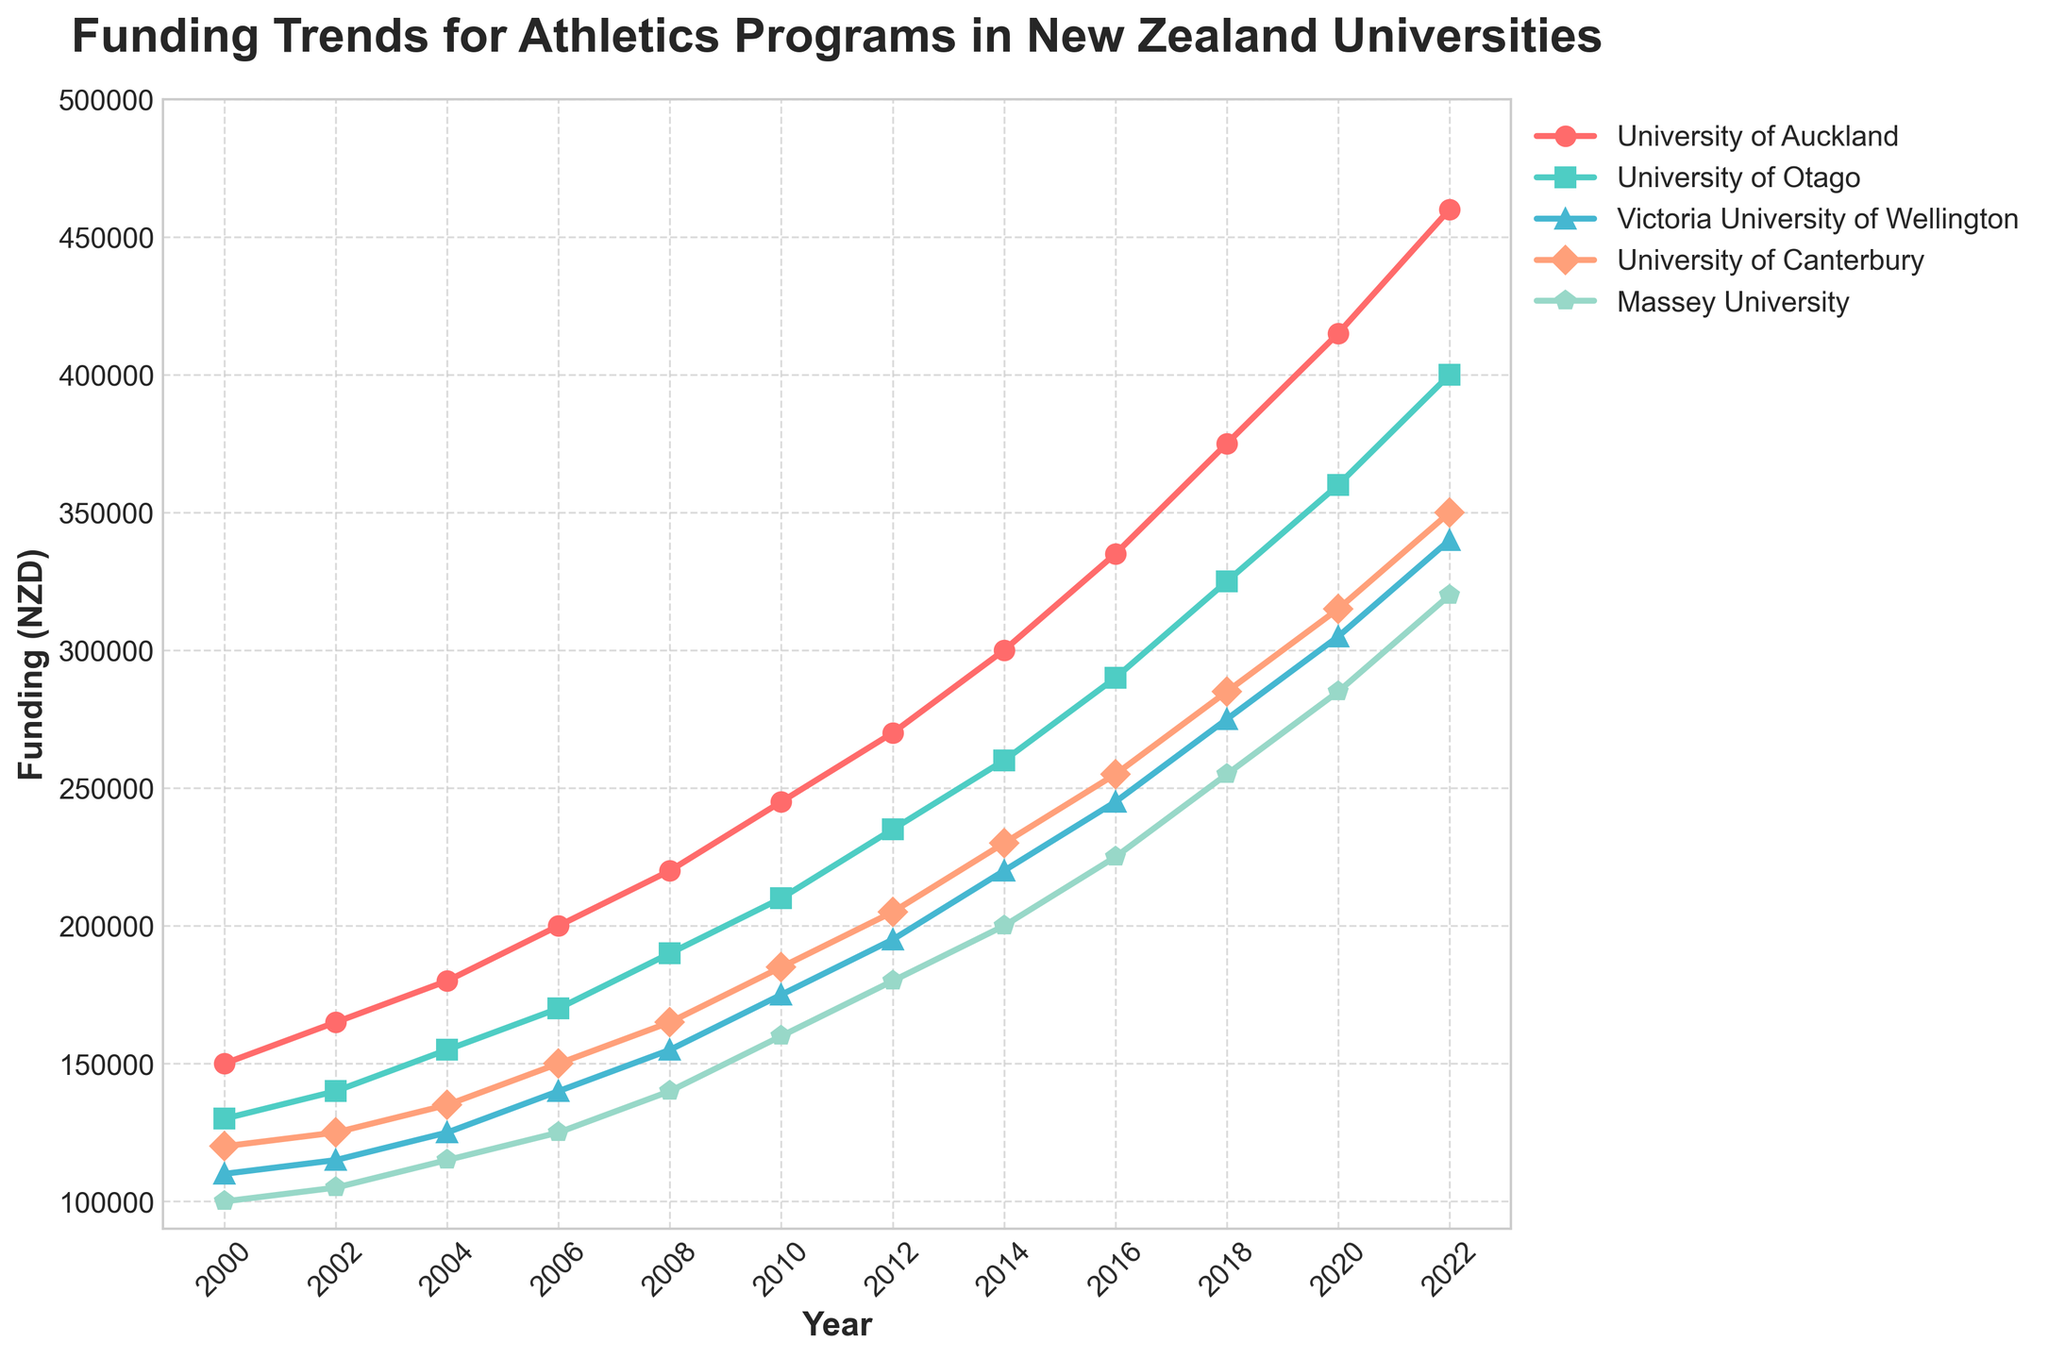What's the overall trend for funding in the University of Auckland from 2000 to 2022? The trend for the University of Auckland from 2000 to 2022 is increasing, starting at 150,000 NZD in 2000 and reaching 460,000 NZD in 2022. This indicates a continuous growth in funding over the years.
Answer: Increasing Which university had the highest funding in 2022? To determine the highest funding in 2022, analyze the values for each university in that year. The University of Auckland had the highest funding at 460,000 NZD.
Answer: University of Auckland How does the funding for the University of Otago in 2010 compare to its funding in 2020? The funding for the University of Otago in 2010 was 210,000 NZD and its funding in 2020 was 360,000 NZD. The funding increased by 150,000 NZD over this period.
Answer: Increased by 150,000 NZD Which university showed the least increase in funding from 2000 to 2022? To find the least increase, calculate the difference for each university from 2000 to 2022: 
- University of Auckland: 460,000 - 150,000 = 310,000
- University of Otago: 400,000 - 130,000 = 270,000
- Victoria University of Wellington: 340,000 - 110,000 = 230,000
- University of Canterbury: 350,000 - 120,000 = 230,000
- Massey University: 320,000 - 100,000 = 220,000
Massey University had the least increase of 220,000 NZD.
Answer: Massey University In which year did Massey University’s funding reach 200,000 NZD? Look for the first year where Massey University's funding is at least 200,000 NZD. This occurred in 2014, when the funding was 200,000 NZD.
Answer: 2014 What is the average funding amount for Victoria University of Wellington across all the years? Sum the funding amounts for all the years and divide by the number of years (12):
(110,000 + 115,000 + 125,000 + 140,000 + 155,000 + 175,000 + 195,000 + 220,000 + 245,000 + 275,000 + 305,000 + 340,000) / 12 = 2,400,000 / 12 = 200,000 NZD
Answer: 200,000 NZD Between the University of Canterbury and Massey University, which had higher funding in 2006 and by how much? University of Canterbury had 150,000 NZD in 2006 and Massey University had 125,000 NZD. The difference is:
150,000 - 125,000 = 25,000 NZD. University of Canterbury had higher funding by 25,000 NZD.
Answer: University of Canterbury by 25,000 NZD Describe the trend of the funding gap between the University of Auckland and the University of Otago from 2000 to 2022. The funding gap can be calculated as:
- 2000: 150,000 - 130,000 = 20,000 NZD
- 2002: 165,000 - 140,000 = 25,000 NZD
- 2004: 180,000 - 155,000 = 25,000 NZD
- 2006: 200,000 - 170,000 = 30,000 NZD
- 2008: 220,000 - 190,000 = 30,000 NZD
- 2010: 245,000 - 210,000 = 35,000 NZD
- 2012: 270,000 - 235,000 = 35,000 NZD
- 2014: 300,000 - 260,000 = 40,000 NZD
- 2016: 335,000 - 290,000 = 45,000 NZD
- 2018: 375,000 - 325,000 = 50,000 NZD
- 2020: 415,000 - 360,000 = 55,000 NZD
- 2022: 460,000 - 400,000 = 60,000 NZD
The gap generally increases over the years.
Answer: Increasing What was the funding for the University of Canterbury in 2008 and 2018, and what is the percentage increase between these two years? Canterbury’s funding in 2008 was 165,000 NZD and in 2018 it was 285,000 NZD. The percentage increase is:
((285,000 - 165,000) / 165,000) * 100 = 72.73%
Answer: 72.73% What is the median funding value for Massey University across all the years? Arrange Massey University funding in order and find the middle value:
100,000, 105,000, 115,000, 125,000, 140,000, 160,000, 180,000, 200,000, 225,000, 255,000, 285,000, 320,000. With 12 values, median is the average of the 6th and 7th values:
(160,000 + 180,000) / 2 = 170,000 NZD
Answer: 170,000 NZD 